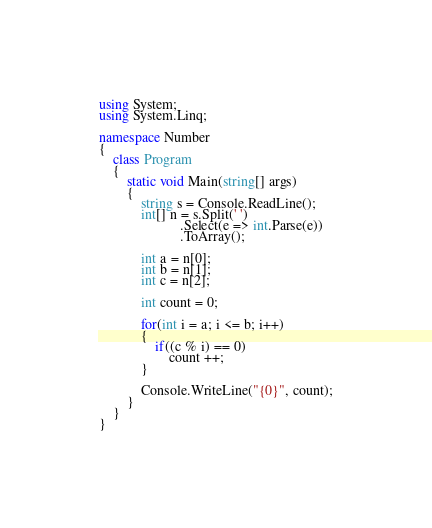<code> <loc_0><loc_0><loc_500><loc_500><_C#_>using System;
using System.Linq;

namespace Number
{
    class Program
    {
        static void Main(string[] args)
        {
            string s = Console.ReadLine();
            int[] n = s.Split(' ')
                       .Select(e => int.Parse(e))
                       .ToArray();
            
            int a = n[0];
            int b = n[1];
            int c = n[2];

            int count = 0;

            for(int i = a; i <= b; i++)
            {
                if((c % i) == 0)
                    count ++;
            }

            Console.WriteLine("{0}", count);
        }
    }
}</code> 